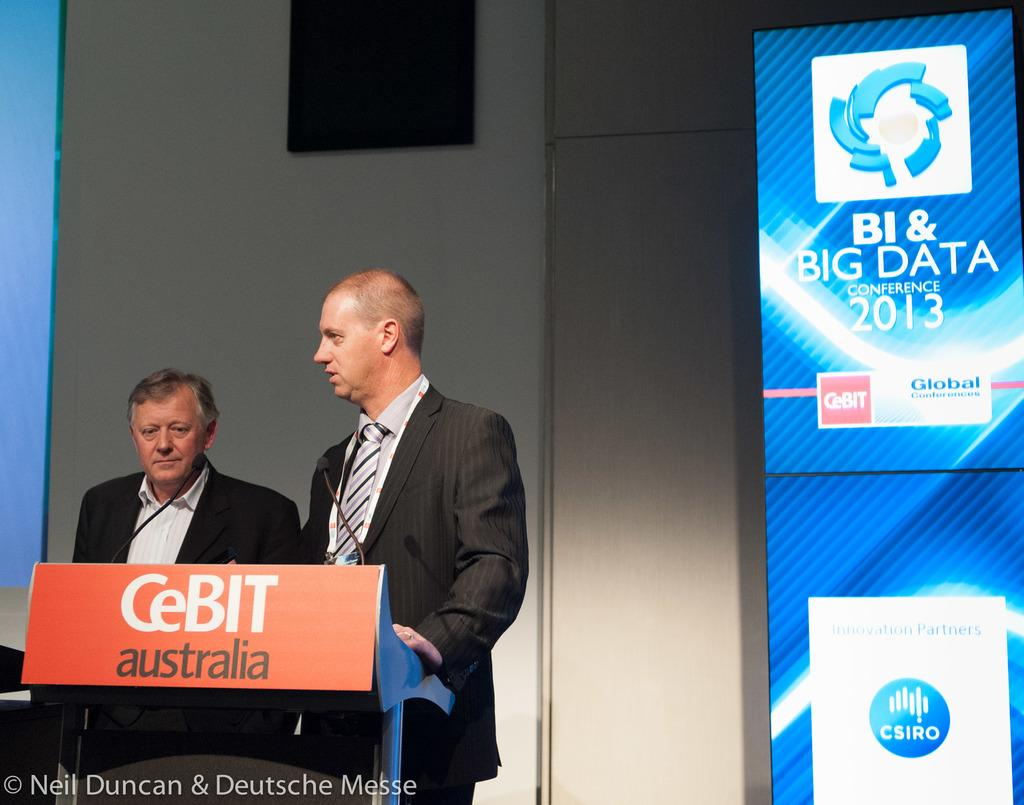How many people are present in the image? There are two men in the image. What are the men doing in the image? The men are talking on a microphone. What object is present in the image that they might be using for support or display? There is a podium in the image. What can be seen in the background of the image? There are hoardings and a wall in the background of the image. What type of marble is visible on the floor in the image? There is no marble visible on the floor in the image. What kind of ring is the man wearing on his finger in the image? There is no ring visible on any of the men's fingers in the image. 